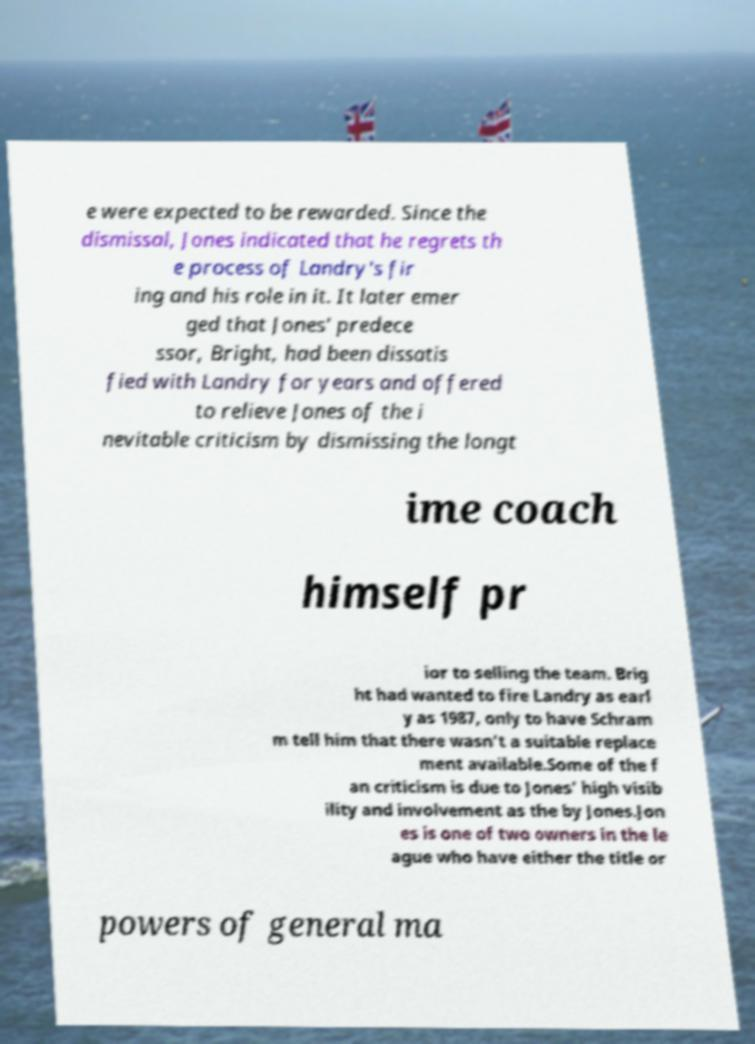There's text embedded in this image that I need extracted. Can you transcribe it verbatim? e were expected to be rewarded. Since the dismissal, Jones indicated that he regrets th e process of Landry's fir ing and his role in it. It later emer ged that Jones' predece ssor, Bright, had been dissatis fied with Landry for years and offered to relieve Jones of the i nevitable criticism by dismissing the longt ime coach himself pr ior to selling the team. Brig ht had wanted to fire Landry as earl y as 1987, only to have Schram m tell him that there wasn't a suitable replace ment available.Some of the f an criticism is due to Jones' high visib ility and involvement as the by Jones.Jon es is one of two owners in the le ague who have either the title or powers of general ma 